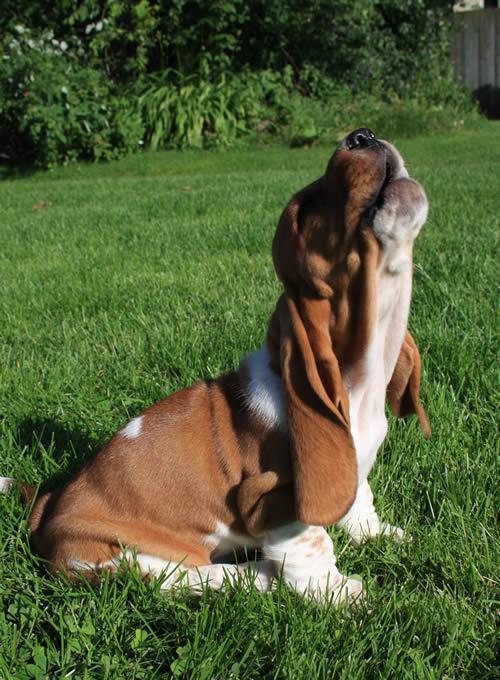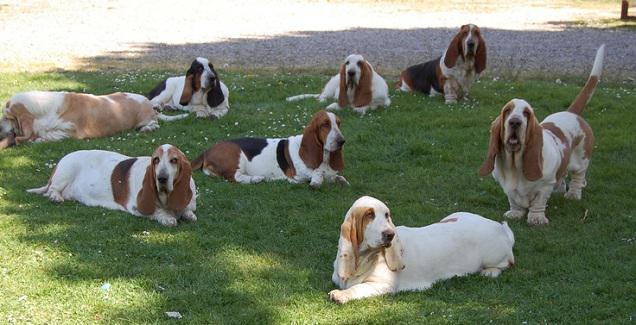The first image is the image on the left, the second image is the image on the right. For the images shown, is this caption "There are four dogs outside in the image on the left." true? Answer yes or no. No. The first image is the image on the left, the second image is the image on the right. Considering the images on both sides, is "In one image, all the dogs are moving away from the camera and all the dogs are basset hounds." valid? Answer yes or no. No. 